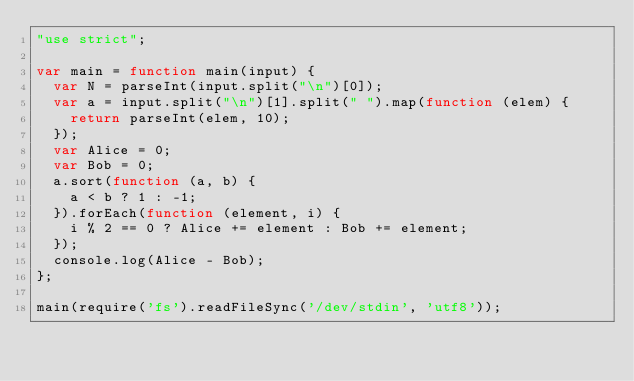Convert code to text. <code><loc_0><loc_0><loc_500><loc_500><_JavaScript_>"use strict";

var main = function main(input) {
  var N = parseInt(input.split("\n")[0]);
  var a = input.split("\n")[1].split(" ").map(function (elem) {
    return parseInt(elem, 10);
  });
  var Alice = 0;
  var Bob = 0;
  a.sort(function (a, b) {
    a < b ? 1 : -1;
  }).forEach(function (element, i) {
    i % 2 == 0 ? Alice += element : Bob += element;
  });
  console.log(Alice - Bob);
};

main(require('fs').readFileSync('/dev/stdin', 'utf8'));</code> 